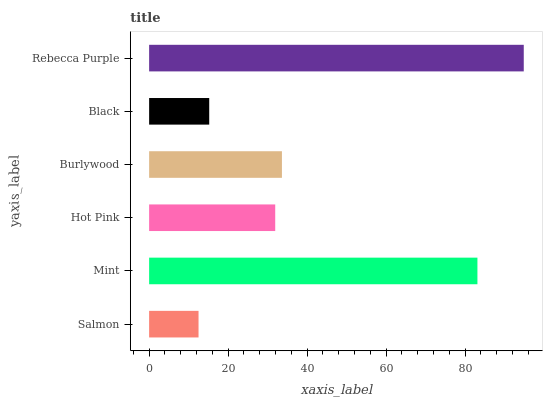Is Salmon the minimum?
Answer yes or no. Yes. Is Rebecca Purple the maximum?
Answer yes or no. Yes. Is Mint the minimum?
Answer yes or no. No. Is Mint the maximum?
Answer yes or no. No. Is Mint greater than Salmon?
Answer yes or no. Yes. Is Salmon less than Mint?
Answer yes or no. Yes. Is Salmon greater than Mint?
Answer yes or no. No. Is Mint less than Salmon?
Answer yes or no. No. Is Burlywood the high median?
Answer yes or no. Yes. Is Hot Pink the low median?
Answer yes or no. Yes. Is Salmon the high median?
Answer yes or no. No. Is Salmon the low median?
Answer yes or no. No. 